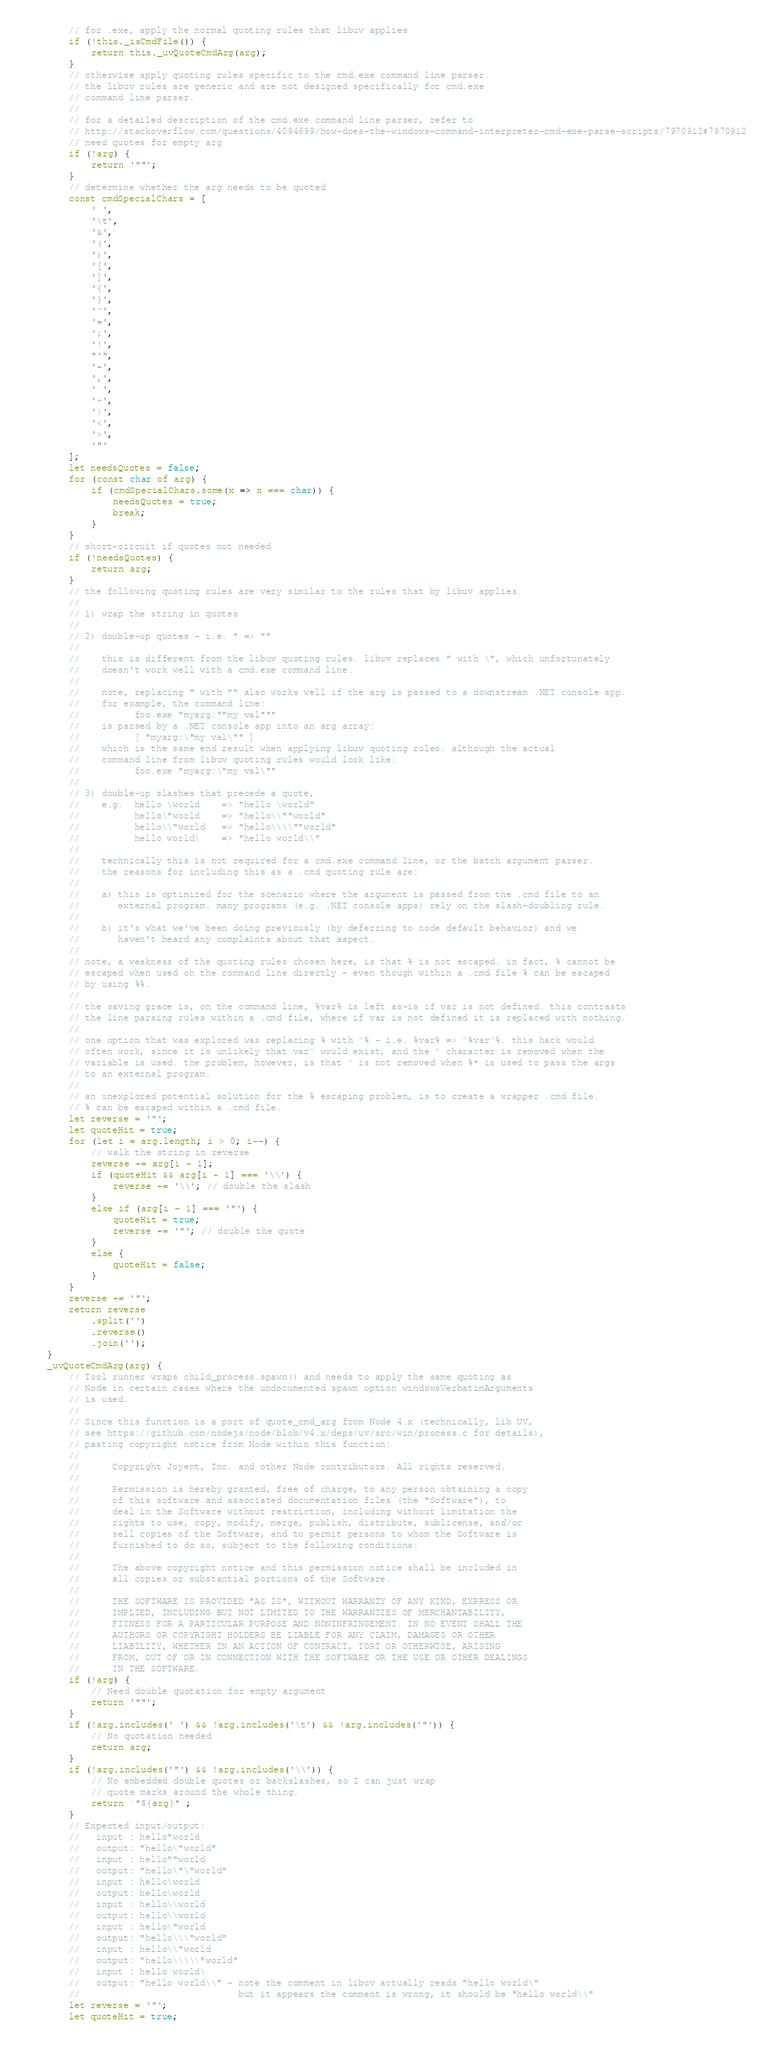Convert code to text. <code><loc_0><loc_0><loc_500><loc_500><_JavaScript_>        // for .exe, apply the normal quoting rules that libuv applies
        if (!this._isCmdFile()) {
            return this._uvQuoteCmdArg(arg);
        }
        // otherwise apply quoting rules specific to the cmd.exe command line parser.
        // the libuv rules are generic and are not designed specifically for cmd.exe
        // command line parser.
        //
        // for a detailed description of the cmd.exe command line parser, refer to
        // http://stackoverflow.com/questions/4094699/how-does-the-windows-command-interpreter-cmd-exe-parse-scripts/7970912#7970912
        // need quotes for empty arg
        if (!arg) {
            return '""';
        }
        // determine whether the arg needs to be quoted
        const cmdSpecialChars = [
            ' ',
            '\t',
            '&',
            '(',
            ')',
            '[',
            ']',
            '{',
            '}',
            '^',
            '=',
            ';',
            '!',
            "'",
            '+',
            ',',
            '`',
            '~',
            '|',
            '<',
            '>',
            '"'
        ];
        let needsQuotes = false;
        for (const char of arg) {
            if (cmdSpecialChars.some(x => x === char)) {
                needsQuotes = true;
                break;
            }
        }
        // short-circuit if quotes not needed
        if (!needsQuotes) {
            return arg;
        }
        // the following quoting rules are very similar to the rules that by libuv applies.
        //
        // 1) wrap the string in quotes
        //
        // 2) double-up quotes - i.e. " => ""
        //
        //    this is different from the libuv quoting rules. libuv replaces " with \", which unfortunately
        //    doesn't work well with a cmd.exe command line.
        //
        //    note, replacing " with "" also works well if the arg is passed to a downstream .NET console app.
        //    for example, the command line:
        //          foo.exe "myarg:""my val"""
        //    is parsed by a .NET console app into an arg array:
        //          [ "myarg:\"my val\"" ]
        //    which is the same end result when applying libuv quoting rules. although the actual
        //    command line from libuv quoting rules would look like:
        //          foo.exe "myarg:\"my val\""
        //
        // 3) double-up slashes that precede a quote,
        //    e.g.  hello \world    => "hello \world"
        //          hello\"world    => "hello\\""world"
        //          hello\\"world   => "hello\\\\""world"
        //          hello world\    => "hello world\\"
        //
        //    technically this is not required for a cmd.exe command line, or the batch argument parser.
        //    the reasons for including this as a .cmd quoting rule are:
        //
        //    a) this is optimized for the scenario where the argument is passed from the .cmd file to an
        //       external program. many programs (e.g. .NET console apps) rely on the slash-doubling rule.
        //
        //    b) it's what we've been doing previously (by deferring to node default behavior) and we
        //       haven't heard any complaints about that aspect.
        //
        // note, a weakness of the quoting rules chosen here, is that % is not escaped. in fact, % cannot be
        // escaped when used on the command line directly - even though within a .cmd file % can be escaped
        // by using %%.
        //
        // the saving grace is, on the command line, %var% is left as-is if var is not defined. this contrasts
        // the line parsing rules within a .cmd file, where if var is not defined it is replaced with nothing.
        //
        // one option that was explored was replacing % with ^% - i.e. %var% => ^%var^%. this hack would
        // often work, since it is unlikely that var^ would exist, and the ^ character is removed when the
        // variable is used. the problem, however, is that ^ is not removed when %* is used to pass the args
        // to an external program.
        //
        // an unexplored potential solution for the % escaping problem, is to create a wrapper .cmd file.
        // % can be escaped within a .cmd file.
        let reverse = '"';
        let quoteHit = true;
        for (let i = arg.length; i > 0; i--) {
            // walk the string in reverse
            reverse += arg[i - 1];
            if (quoteHit && arg[i - 1] === '\\') {
                reverse += '\\'; // double the slash
            }
            else if (arg[i - 1] === '"') {
                quoteHit = true;
                reverse += '"'; // double the quote
            }
            else {
                quoteHit = false;
            }
        }
        reverse += '"';
        return reverse
            .split('')
            .reverse()
            .join('');
    }
    _uvQuoteCmdArg(arg) {
        // Tool runner wraps child_process.spawn() and needs to apply the same quoting as
        // Node in certain cases where the undocumented spawn option windowsVerbatimArguments
        // is used.
        //
        // Since this function is a port of quote_cmd_arg from Node 4.x (technically, lib UV,
        // see https://github.com/nodejs/node/blob/v4.x/deps/uv/src/win/process.c for details),
        // pasting copyright notice from Node within this function:
        //
        //      Copyright Joyent, Inc. and other Node contributors. All rights reserved.
        //
        //      Permission is hereby granted, free of charge, to any person obtaining a copy
        //      of this software and associated documentation files (the "Software"), to
        //      deal in the Software without restriction, including without limitation the
        //      rights to use, copy, modify, merge, publish, distribute, sublicense, and/or
        //      sell copies of the Software, and to permit persons to whom the Software is
        //      furnished to do so, subject to the following conditions:
        //
        //      The above copyright notice and this permission notice shall be included in
        //      all copies or substantial portions of the Software.
        //
        //      THE SOFTWARE IS PROVIDED "AS IS", WITHOUT WARRANTY OF ANY KIND, EXPRESS OR
        //      IMPLIED, INCLUDING BUT NOT LIMITED TO THE WARRANTIES OF MERCHANTABILITY,
        //      FITNESS FOR A PARTICULAR PURPOSE AND NONINFRINGEMENT. IN NO EVENT SHALL THE
        //      AUTHORS OR COPYRIGHT HOLDERS BE LIABLE FOR ANY CLAIM, DAMAGES OR OTHER
        //      LIABILITY, WHETHER IN AN ACTION OF CONTRACT, TORT OR OTHERWISE, ARISING
        //      FROM, OUT OF OR IN CONNECTION WITH THE SOFTWARE OR THE USE OR OTHER DEALINGS
        //      IN THE SOFTWARE.
        if (!arg) {
            // Need double quotation for empty argument
            return '""';
        }
        if (!arg.includes(' ') && !arg.includes('\t') && !arg.includes('"')) {
            // No quotation needed
            return arg;
        }
        if (!arg.includes('"') && !arg.includes('\\')) {
            // No embedded double quotes or backslashes, so I can just wrap
            // quote marks around the whole thing.
            return `"${arg}"`;
        }
        // Expected input/output:
        //   input : hello"world
        //   output: "hello\"world"
        //   input : hello""world
        //   output: "hello\"\"world"
        //   input : hello\world
        //   output: hello\world
        //   input : hello\\world
        //   output: hello\\world
        //   input : hello\"world
        //   output: "hello\\\"world"
        //   input : hello\\"world
        //   output: "hello\\\\\"world"
        //   input : hello world\
        //   output: "hello world\\" - note the comment in libuv actually reads "hello world\"
        //                             but it appears the comment is wrong, it should be "hello world\\"
        let reverse = '"';
        let quoteHit = true;</code> 